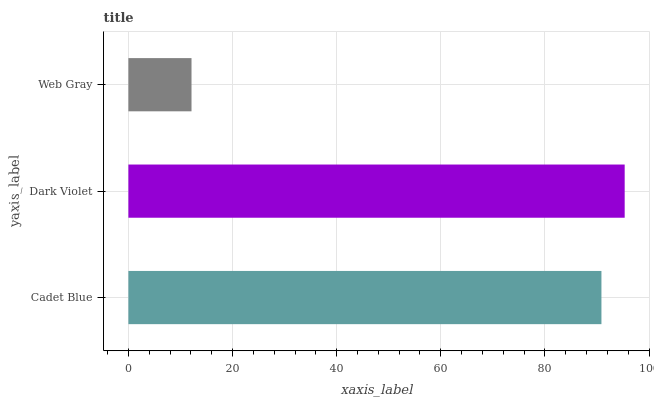Is Web Gray the minimum?
Answer yes or no. Yes. Is Dark Violet the maximum?
Answer yes or no. Yes. Is Dark Violet the minimum?
Answer yes or no. No. Is Web Gray the maximum?
Answer yes or no. No. Is Dark Violet greater than Web Gray?
Answer yes or no. Yes. Is Web Gray less than Dark Violet?
Answer yes or no. Yes. Is Web Gray greater than Dark Violet?
Answer yes or no. No. Is Dark Violet less than Web Gray?
Answer yes or no. No. Is Cadet Blue the high median?
Answer yes or no. Yes. Is Cadet Blue the low median?
Answer yes or no. Yes. Is Web Gray the high median?
Answer yes or no. No. Is Dark Violet the low median?
Answer yes or no. No. 